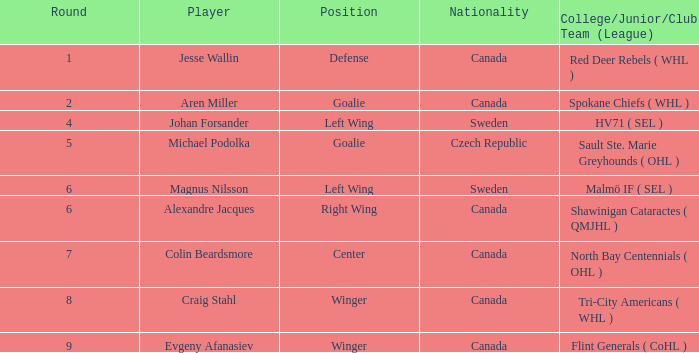Help me parse the entirety of this table. {'header': ['Round', 'Player', 'Position', 'Nationality', 'College/Junior/Club Team (League)'], 'rows': [['1', 'Jesse Wallin', 'Defense', 'Canada', 'Red Deer Rebels ( WHL )'], ['2', 'Aren Miller', 'Goalie', 'Canada', 'Spokane Chiefs ( WHL )'], ['4', 'Johan Forsander', 'Left Wing', 'Sweden', 'HV71 ( SEL )'], ['5', 'Michael Podolka', 'Goalie', 'Czech Republic', 'Sault Ste. Marie Greyhounds ( OHL )'], ['6', 'Magnus Nilsson', 'Left Wing', 'Sweden', 'Malmö IF ( SEL )'], ['6', 'Alexandre Jacques', 'Right Wing', 'Canada', 'Shawinigan Cataractes ( QMJHL )'], ['7', 'Colin Beardsmore', 'Center', 'Canada', 'North Bay Centennials ( OHL )'], ['8', 'Craig Stahl', 'Winger', 'Canada', 'Tri-City Americans ( WHL )'], ['9', 'Evgeny Afanasiev', 'Winger', 'Canada', 'Flint Generals ( CoHL )']]} What is the School/Junior/Club Group (Class) that has a Nationality of canada, and a Place of goalie? Spokane Chiefs ( WHL ). 